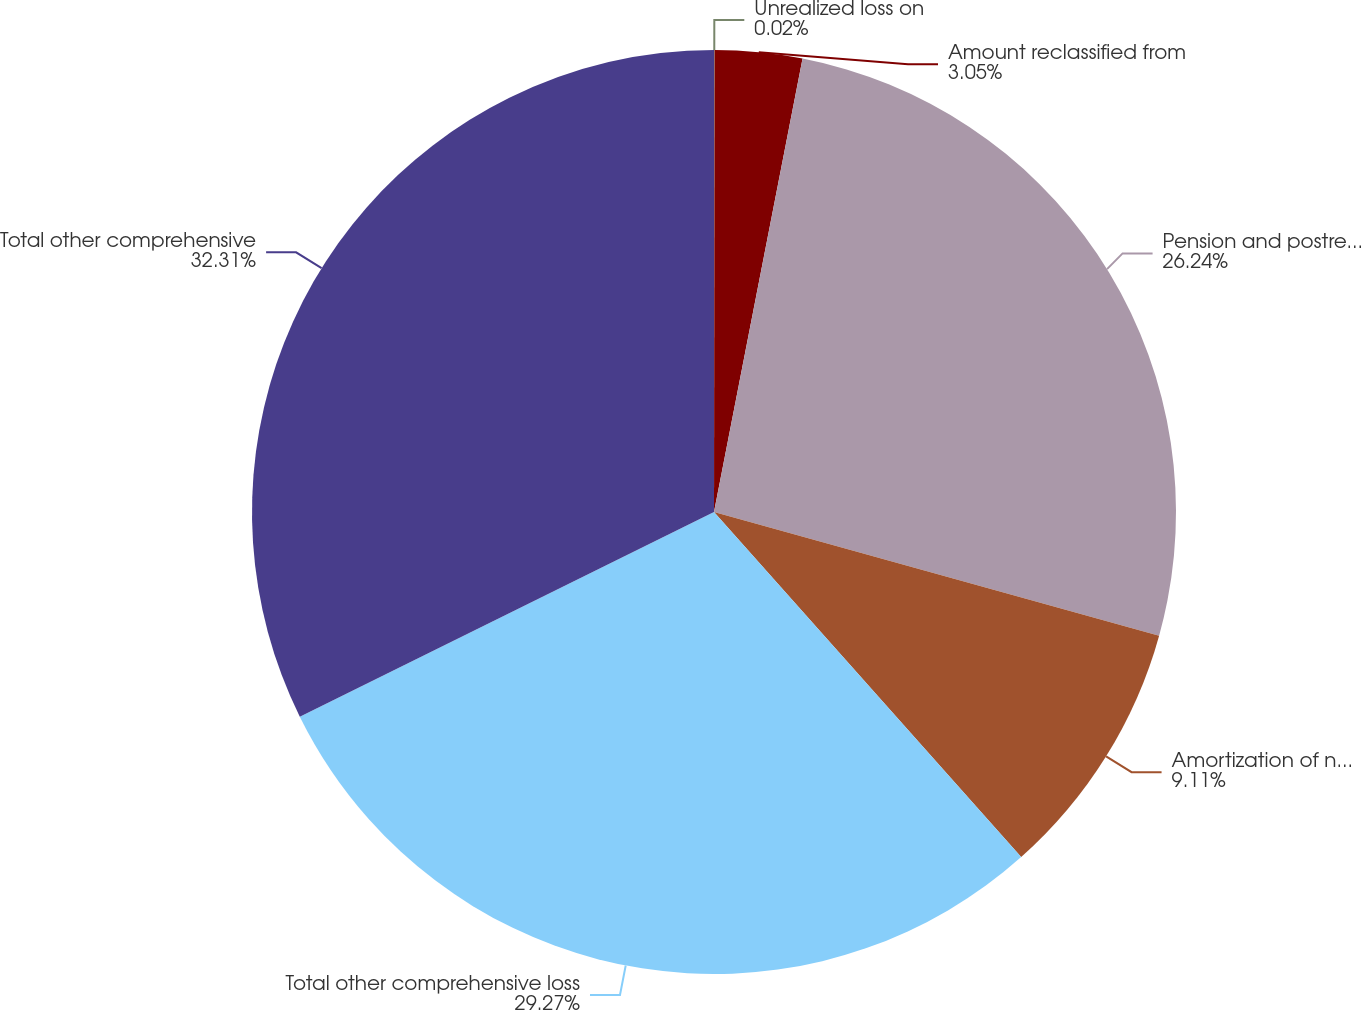<chart> <loc_0><loc_0><loc_500><loc_500><pie_chart><fcel>Unrealized loss on<fcel>Amount reclassified from<fcel>Pension and postretirement<fcel>Amortization of net actuarial<fcel>Total other comprehensive loss<fcel>Total other comprehensive<nl><fcel>0.02%<fcel>3.05%<fcel>26.24%<fcel>9.11%<fcel>29.27%<fcel>32.3%<nl></chart> 